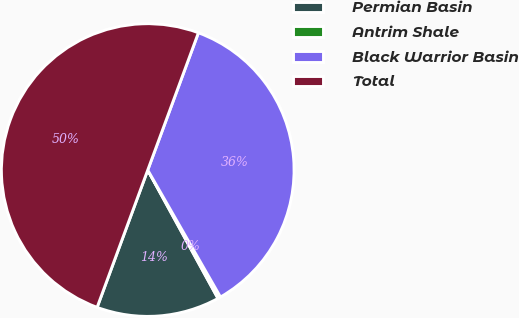Convert chart. <chart><loc_0><loc_0><loc_500><loc_500><pie_chart><fcel>Permian Basin<fcel>Antrim Shale<fcel>Black Warrior Basin<fcel>Total<nl><fcel>13.59%<fcel>0.31%<fcel>36.09%<fcel>50.0%<nl></chart> 